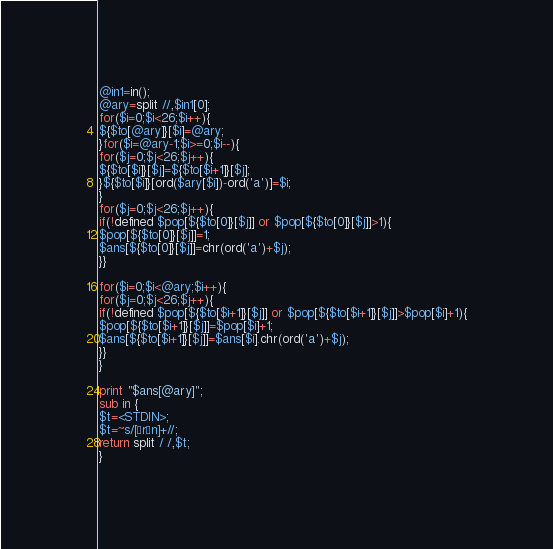Convert code to text. <code><loc_0><loc_0><loc_500><loc_500><_Perl_>@in1=in();
@ary=split //,$in1[0];
for($i=0;$i<26;$i++){
${$to[@ary]}[$i]=@ary;
}for($i=@ary-1;$i>=0;$i--){
for($j=0;$j<26;$j++){
${$to[$i]}[$j]=${$to[$i+1]}[$j];
}${$to[$i]}[ord($ary[$i])-ord('a')]=$i;
}
for($j=0;$j<26;$j++){
if(!defined $pop[${$to[0]}[$j]] or $pop[${$to[0]}[$j]]>1){
$pop[${$to[0]}[$j]]=1;
$ans[${$to[0]}[$j]]=chr(ord('a')+$j);
}}

for($i=0;$i<@ary;$i++){
for($j=0;$j<26;$j++){
if(!defined $pop[${$to[$i+1]}[$j]] or $pop[${$to[$i+1]}[$j]]>$pop[$i]+1){
$pop[${$to[$i+1]}[$j]]=$pop[$i]+1;
$ans[${$to[$i+1]}[$j]]=$ans[$i].chr(ord('a')+$j);
}}
}

print "$ans[@ary]";
sub in {
$t=<STDIN>;
$t=~s/[¥r¥n]+//;
return split / /,$t;
}
</code> 